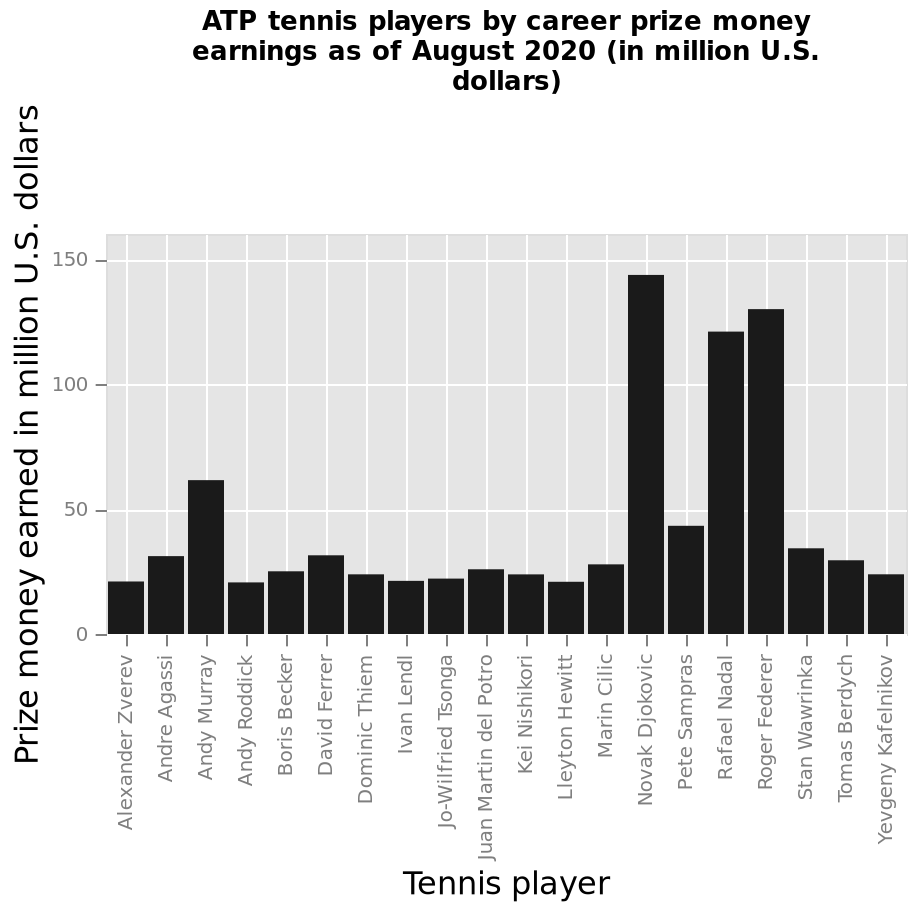<image>
please enumerates aspects of the construction of the chart Here a is a bar plot named ATP tennis players by career prize money earnings as of August 2020 (in million U.S. dollars). The x-axis measures Tennis player along categorical scale starting at Alexander Zverev and ending at Yevgeny Kafelnikov while the y-axis measures Prize money earned in million U.S. dollars as linear scale of range 0 to 150. Offer a thorough analysis of the image. Novak Djokovic, Rafael Nadal and Roger Federer are marked as the top 3 ATP tennis players by career prize money earned as in August of 2020 a significant difference compared to the other 17 players. The other players do not exceed the 50 million mark by the exception of Andy Murray. How many players have exceeded the 50 million mark in career prize money earned as of August 2020?  Only three players have exceeded the 50 million mark: Novak Djokovic, Rafael Nadal, and Roger Federer. What does the y-axis measure on the bar plot? The y-axis measures prize money earned in million U.S. dollars on a linear scale ranging from 0 to 150. Is there any player among the other 17 players who has surpassed the 50 million mark in career prize money earned as of August 2020? No, except for Andy Murray, the other 17 players have not exceeded the 50 million mark. Who is the exception among the other players who have not exceeded the 50 million mark in career prize money earned as of August 2020? Andy Murray is the exception. What is the name of the bar plot? The bar plot is named "ATP tennis players by career prize money earnings as of August 2020 (in million U.S. dollars)". 